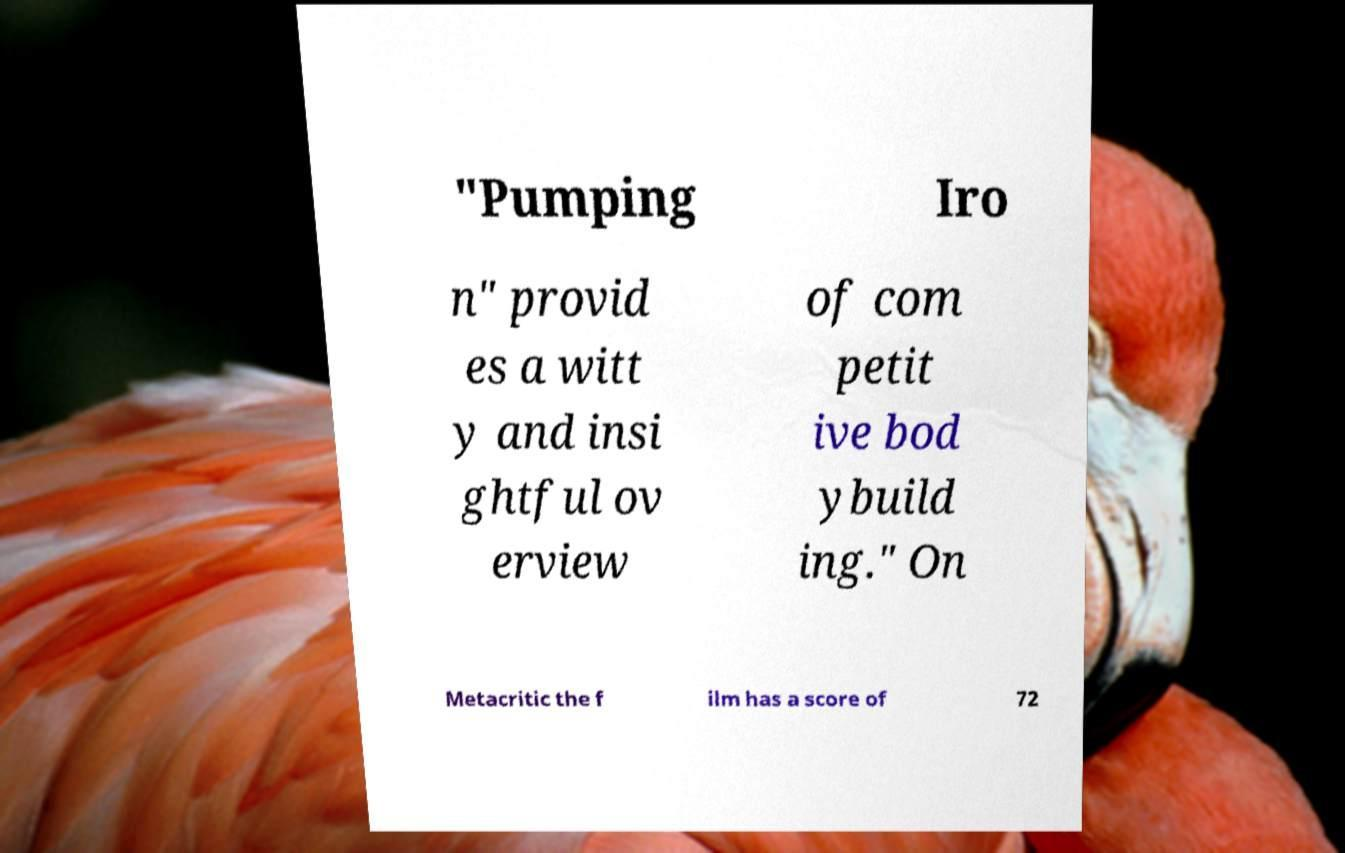For documentation purposes, I need the text within this image transcribed. Could you provide that? "Pumping Iro n" provid es a witt y and insi ghtful ov erview of com petit ive bod ybuild ing." On Metacritic the f ilm has a score of 72 